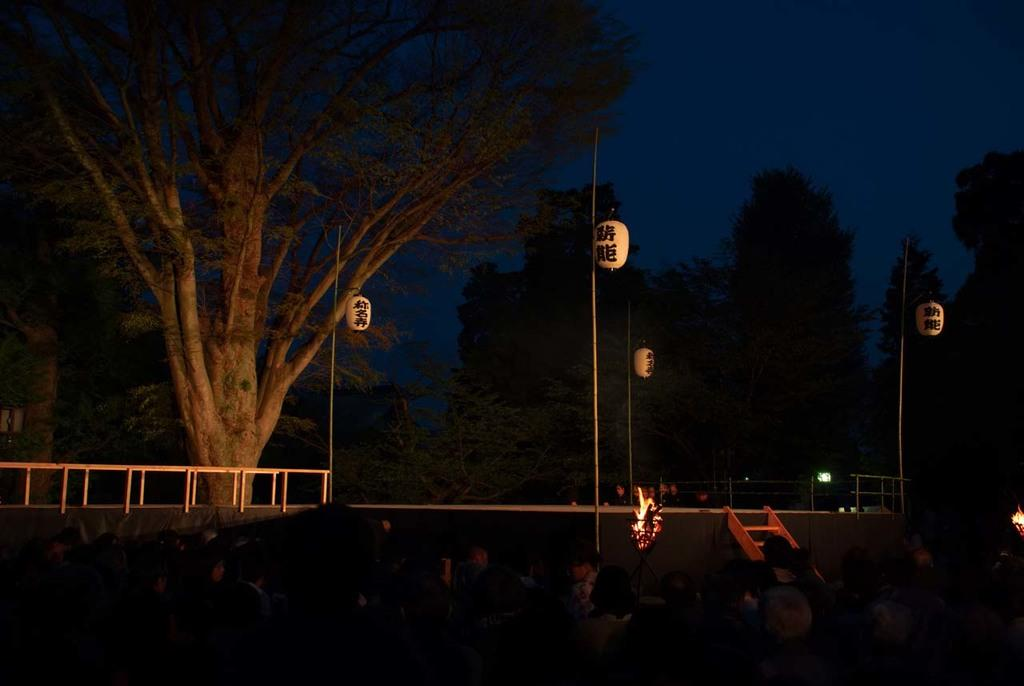How many people are in the image? There is a group of people in the image, but the exact number is not specified. What can be seen in the background of the image? In the background of the image, there is a ladder, trees, fire, the sky, and some unspecified objects. What might the fire be used for in the image? The purpose of the fire in the image is not specified, but it could be used for warmth, cooking, or a controlled burn. What type of flowers are blooming near the dinosaurs in the image? There are no dinosaurs or flowers present in the image. 